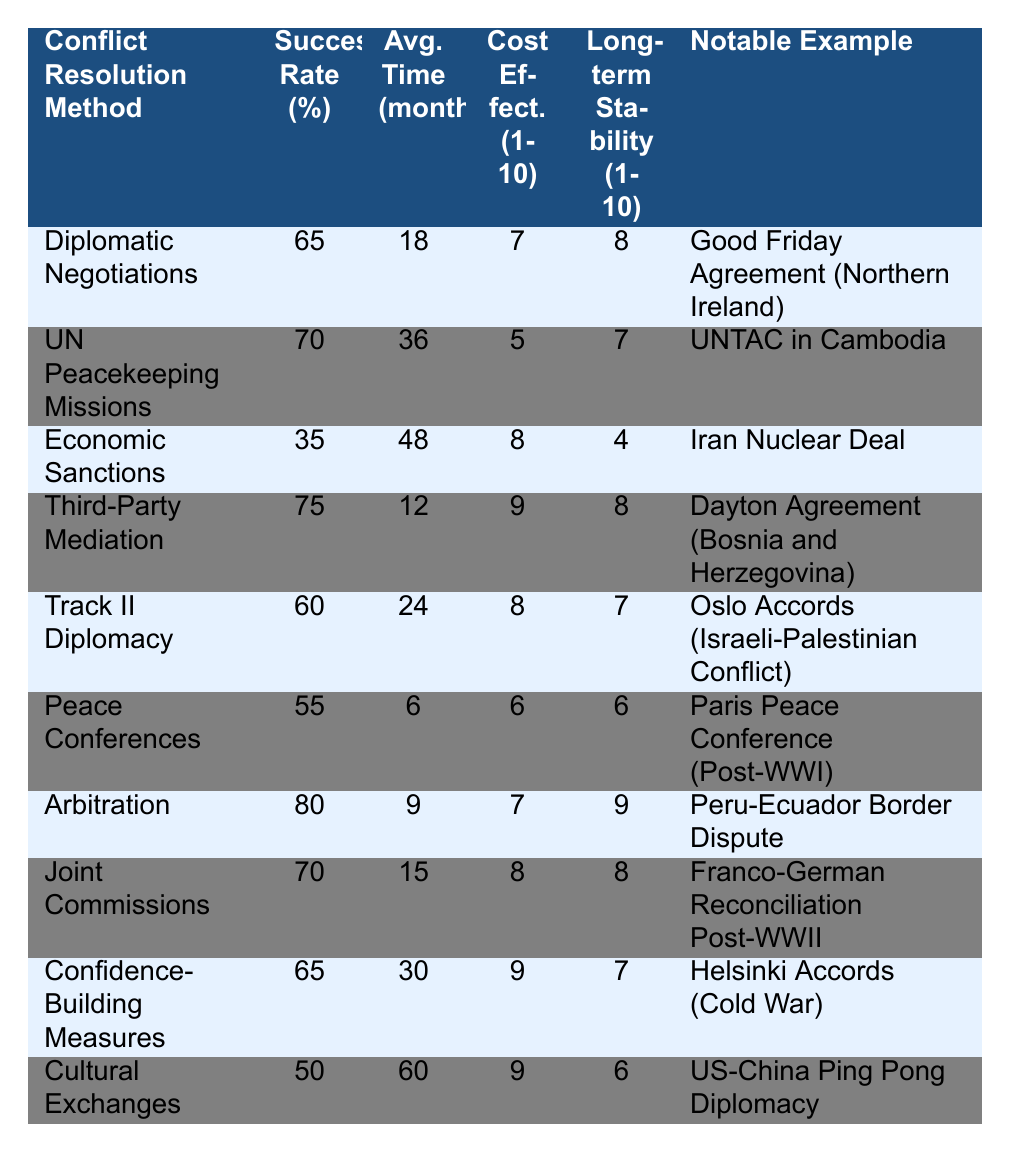What is the success rate of Third-Party Mediation? The table shows the success rate for Third-Party Mediation is listed as 75%.
Answer: 75% Which conflict resolution method has the highest long-term stability rating? The table indicates that Arbitration has a long-term stability rating of 9, which is the highest among all methods listed.
Answer: Arbitration What is the average time to resolution for Economic Sanctions? According to the table, the average time to resolution for Economic Sanctions is 48 months.
Answer: 48 months Is the success rate of Joint Commissions greater than 60%? The success rate for Joint Commissions is 70%, which is indeed greater than 60%.
Answer: Yes Which method has a cost effectiveness rating of 5? The table shows that UN Peacekeeping Missions have a cost-effectiveness rating of 5.
Answer: UN Peacekeeping Missions Calculate the average success rate of all listed conflict resolution methods. The success rates are 65, 70, 35, 75, 60, 55, 80, 70, 65, and 50. Summing these numbers gives 65 + 70 + 35 + 75 + 60 + 55 + 80 + 70 + 65 + 50 =  695. There are 10 methods, so the average success rate is 695 / 10 = 69.5%.
Answer: 69.5% What notable example corresponds to the Cultural Exchanges method? The notable example for Cultural Exchanges, as per the table, is US-China Ping Pong Diplomacy.
Answer: US-China Ping Pong Diplomacy Which conflict resolution method is both cost-effective (rating 9) and has a high success rate (over 70%)? The only method meeting these criteria is Third-Party Mediation, which has a success rate of 75% and a cost-effectiveness rating of 9.
Answer: Third-Party Mediation What is the difference in success rates between Arbitration and Economic Sanctions? Arbitration has a success rate of 80%, while Economic Sanctions have a success rate of 35%. The difference is 80 - 35 = 45%.
Answer: 45% Which methods have an average time to resolution of 15 months or less? The table indicates that the methods meeting this criterion are Third-Party Mediation (12 months), Arbitration (9 months), and Peace Conferences (6 months). These are the only methods with an average resolution time less than or equal to 15 months.
Answer: Third-Party Mediation, Arbitration, Peace Conferences 